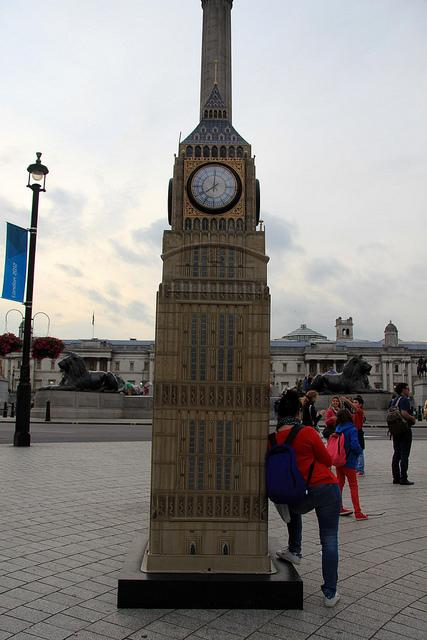What public service does the structure seen here serve?

Choices:
A) time keeping
B) security
C) policing
D) cleaning time keeping 